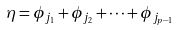Convert formula to latex. <formula><loc_0><loc_0><loc_500><loc_500>\eta = \phi _ { j _ { 1 } } + \phi _ { j _ { 2 } } + \dots + \phi _ { j _ { p - 1 } }</formula> 